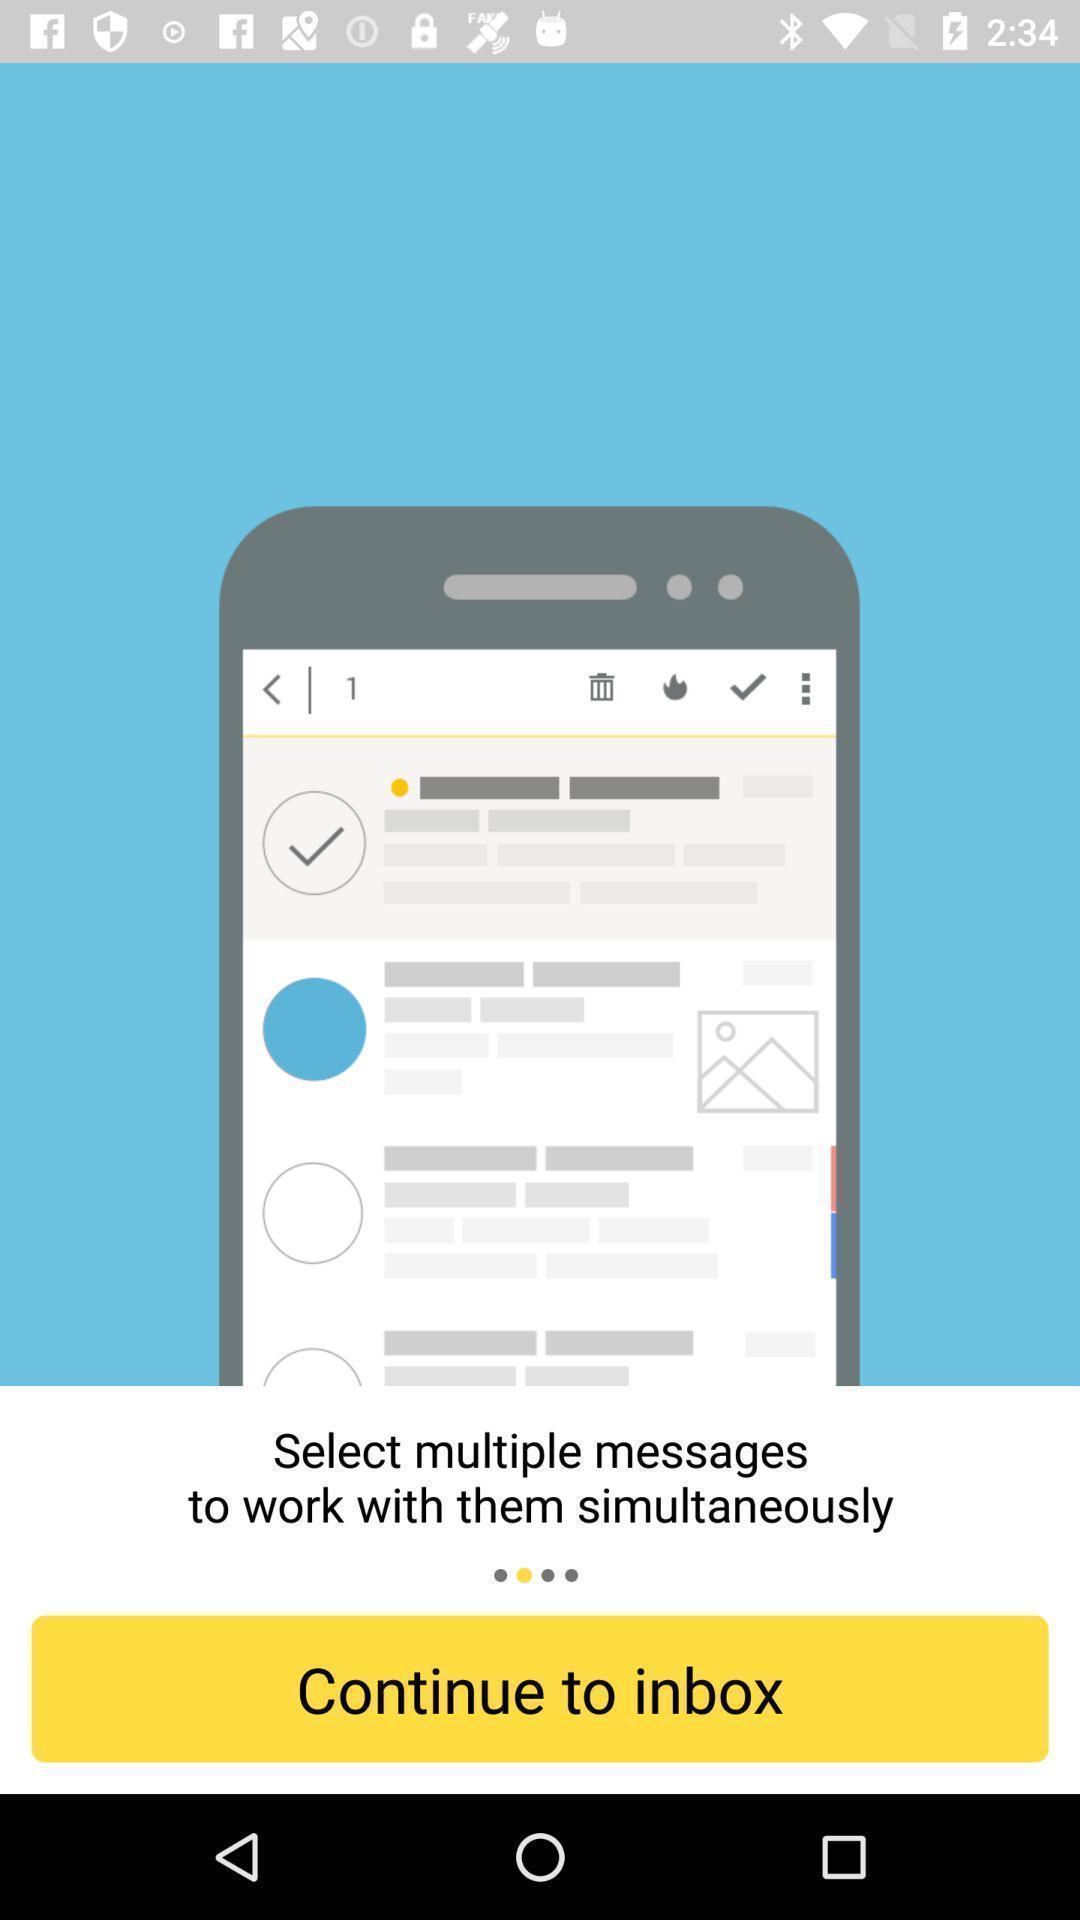Provide a textual representation of this image. Page showing to select multiple messages for mailing app. 